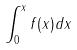Convert formula to latex. <formula><loc_0><loc_0><loc_500><loc_500>\int _ { 0 } ^ { x } f ( x ) d x</formula> 